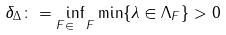Convert formula to latex. <formula><loc_0><loc_0><loc_500><loc_500>\delta _ { \Delta } \colon = \inf _ { F \in \ F } \min \{ \lambda \in \Lambda _ { F } \} > 0</formula> 